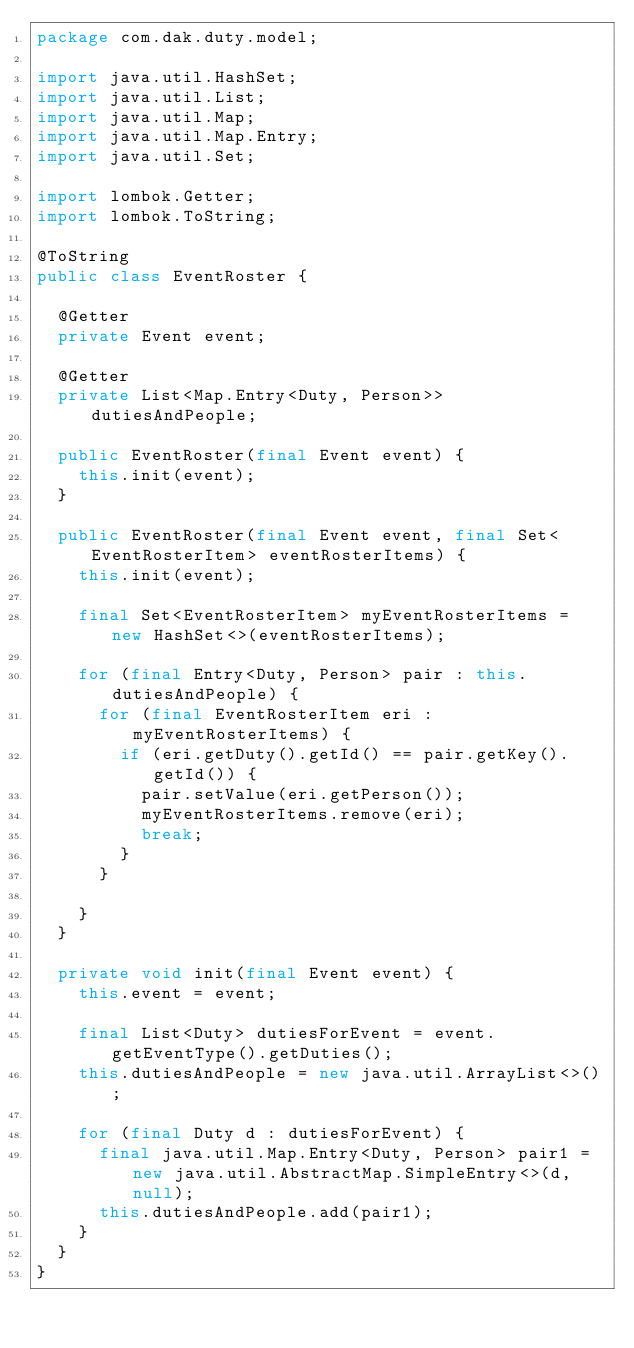Convert code to text. <code><loc_0><loc_0><loc_500><loc_500><_Java_>package com.dak.duty.model;

import java.util.HashSet;
import java.util.List;
import java.util.Map;
import java.util.Map.Entry;
import java.util.Set;

import lombok.Getter;
import lombok.ToString;

@ToString
public class EventRoster {

	@Getter
	private Event event;

	@Getter
	private List<Map.Entry<Duty, Person>> dutiesAndPeople;

	public EventRoster(final Event event) {
		this.init(event);
	}

	public EventRoster(final Event event, final Set<EventRosterItem> eventRosterItems) {
		this.init(event);

		final Set<EventRosterItem> myEventRosterItems = new HashSet<>(eventRosterItems);

		for (final Entry<Duty, Person> pair : this.dutiesAndPeople) {
			for (final EventRosterItem eri : myEventRosterItems) {
				if (eri.getDuty().getId() == pair.getKey().getId()) {
					pair.setValue(eri.getPerson());
					myEventRosterItems.remove(eri);
					break;
				}
			}

		}
	}

	private void init(final Event event) {
		this.event = event;

		final List<Duty> dutiesForEvent = event.getEventType().getDuties();
		this.dutiesAndPeople = new java.util.ArrayList<>();

		for (final Duty d : dutiesForEvent) {
			final java.util.Map.Entry<Duty, Person> pair1 = new java.util.AbstractMap.SimpleEntry<>(d, null);
			this.dutiesAndPeople.add(pair1);
		}
	}
}
</code> 